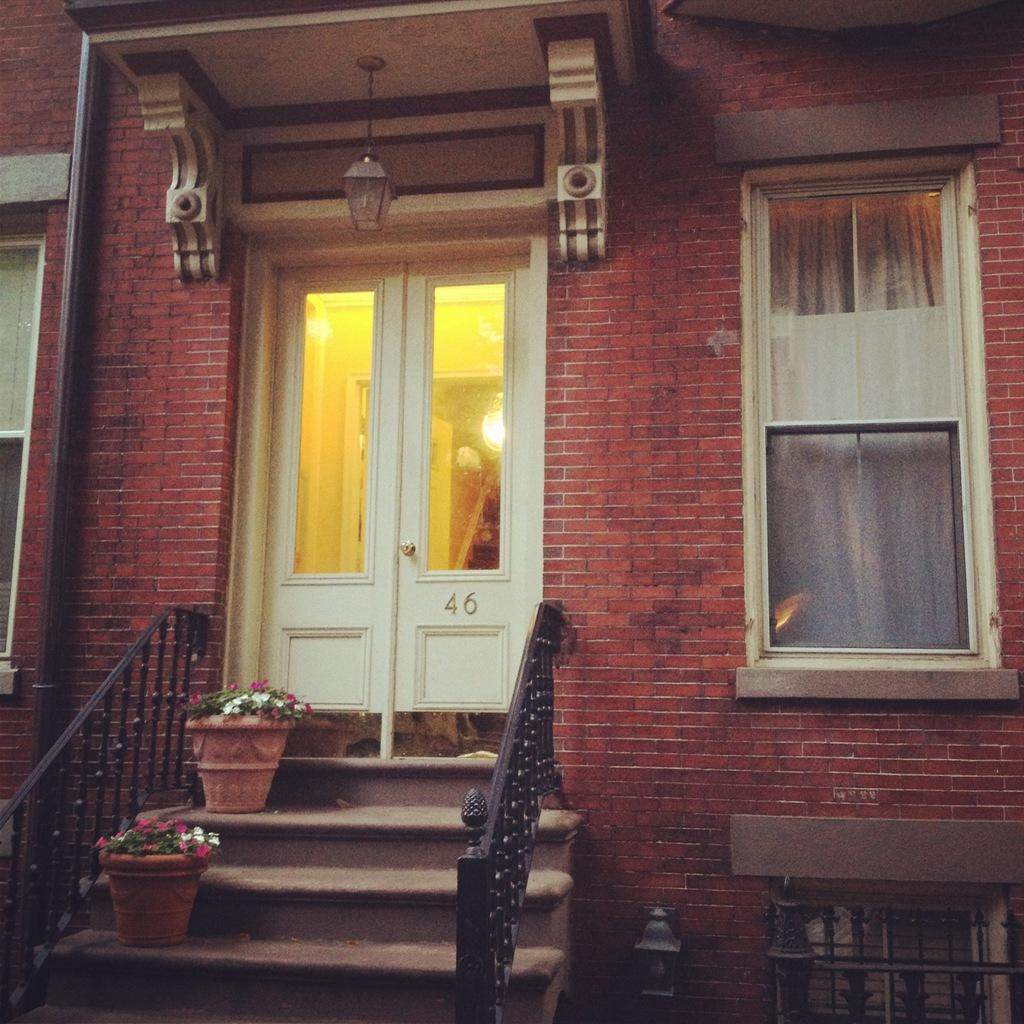What type of structure can be seen in the image? There is a wall in the image. What architectural feature is present in the image? There are stairs in the image. What can be seen through the window in the image? There is no information about what can be seen through the window. What is placed near the window in the image? There is a pot with flowers in the image. What is the purpose of the door in the image? The purpose of the door is to provide access to the room or area. What type of teaching is happening in the image? There is no teaching activity present in the image. What appliance can be seen in the image? There is no appliance present in the image. 